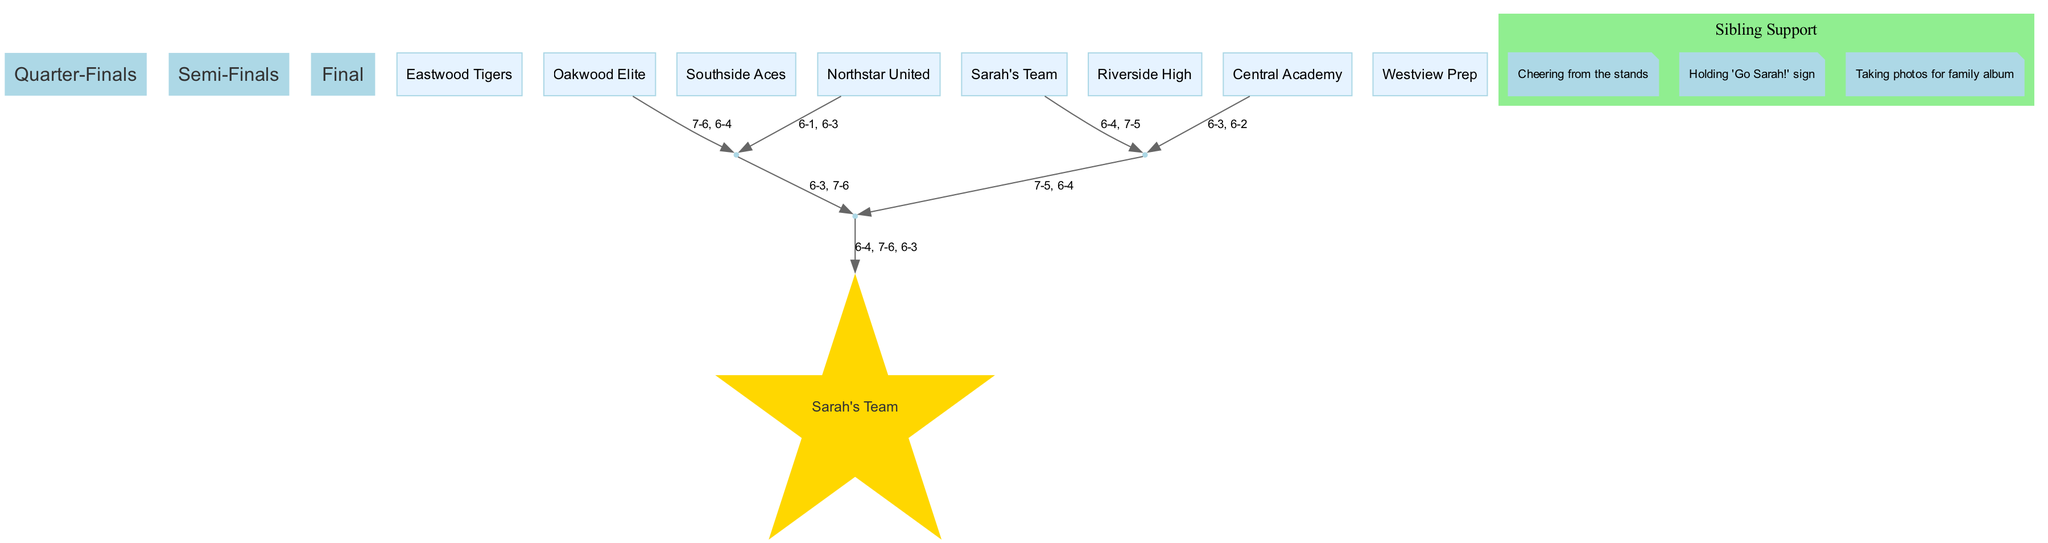What are the names of the teams in the tournament? The teams listed in the diagram include Sarah's Team, Riverside High, Central Academy, Westview Prep, Oakwood Elite, Southside Aces, Northstar United, and Eastwood Tigers.
Answer: Sarah's Team, Riverside High, Central Academy, Westview Prep, Oakwood Elite, Southside Aces, Northstar United, Eastwood Tigers How many rounds are in the tournament? The rounds outlined in the diagram are Quarter-Finals, Semi-Finals, and Final, which totals three rounds.
Answer: 3 Who won the Semi-Finals matches? The winners of the Semi-Finals are Sarah's Team and Oakwood Elite, as per the results shown in the diagram.
Answer: Sarah's Team, Oakwood Elite What is the score of the final match? The final match score is represented as 6-4, 7-6, 6-3, indicating the match results of the final between Sarah's Team and Oakwood Elite.
Answer: 6-4, 7-6, 6-3 Which team defeated Riverside High? From the Quarter-Finals results, Sarah's Team is shown to have defeated Riverside High in their match.
Answer: Sarah's Team How many matches did Sarah's Team win to become the champion? Sarah's Team won a total of three matches: one in the Quarter-Finals, one in the Semi-Finals, and one in the Final, leading them to be crowned champion.
Answer: 3 Which team faced Oakwood Elite in the Semi-Finals? The team that faced Oakwood Elite in the Semi-Finals, as indicated in the diagram, is Northstar United.
Answer: Northstar United What action did the sibling take during the tournament? The sibling was actively cheering from the stands, signifying their support during the matches.
Answer: Cheering from the stands What was the name of the champion team? According to the results represented in the diagram, the champion team is Sarah's Team.
Answer: Sarah's Team 